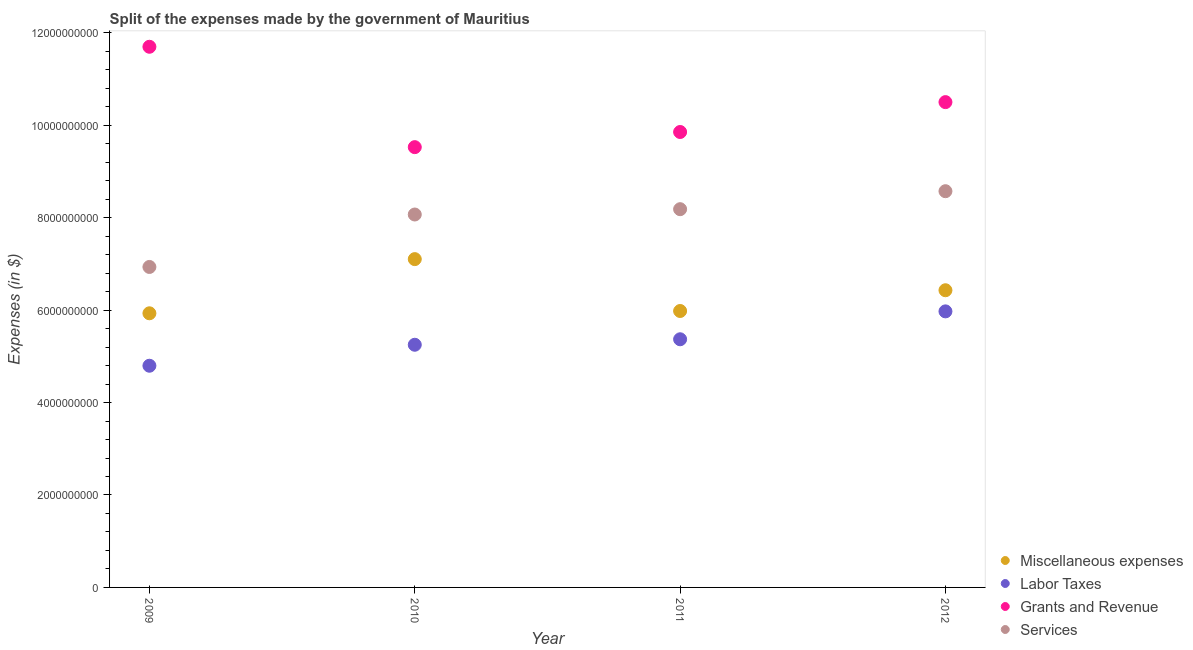Is the number of dotlines equal to the number of legend labels?
Ensure brevity in your answer.  Yes. What is the amount spent on miscellaneous expenses in 2011?
Provide a succinct answer. 5.98e+09. Across all years, what is the maximum amount spent on miscellaneous expenses?
Provide a succinct answer. 7.10e+09. Across all years, what is the minimum amount spent on labor taxes?
Your answer should be compact. 4.80e+09. In which year was the amount spent on grants and revenue maximum?
Your response must be concise. 2009. In which year was the amount spent on miscellaneous expenses minimum?
Ensure brevity in your answer.  2009. What is the total amount spent on services in the graph?
Provide a succinct answer. 3.18e+1. What is the difference between the amount spent on services in 2010 and that in 2012?
Your response must be concise. -5.04e+08. What is the difference between the amount spent on grants and revenue in 2011 and the amount spent on services in 2010?
Your answer should be compact. 1.79e+09. What is the average amount spent on grants and revenue per year?
Your answer should be compact. 1.04e+1. In the year 2010, what is the difference between the amount spent on services and amount spent on grants and revenue?
Give a very brief answer. -1.46e+09. What is the ratio of the amount spent on labor taxes in 2009 to that in 2012?
Your answer should be very brief. 0.8. Is the difference between the amount spent on labor taxes in 2010 and 2012 greater than the difference between the amount spent on grants and revenue in 2010 and 2012?
Provide a succinct answer. Yes. What is the difference between the highest and the second highest amount spent on services?
Provide a short and direct response. 3.89e+08. What is the difference between the highest and the lowest amount spent on services?
Provide a succinct answer. 1.64e+09. Is it the case that in every year, the sum of the amount spent on services and amount spent on miscellaneous expenses is greater than the sum of amount spent on labor taxes and amount spent on grants and revenue?
Provide a short and direct response. No. Does the amount spent on grants and revenue monotonically increase over the years?
Keep it short and to the point. No. Is the amount spent on labor taxes strictly greater than the amount spent on miscellaneous expenses over the years?
Your response must be concise. No. What is the difference between two consecutive major ticks on the Y-axis?
Keep it short and to the point. 2.00e+09. Where does the legend appear in the graph?
Your answer should be very brief. Bottom right. What is the title of the graph?
Offer a terse response. Split of the expenses made by the government of Mauritius. What is the label or title of the X-axis?
Provide a succinct answer. Year. What is the label or title of the Y-axis?
Keep it short and to the point. Expenses (in $). What is the Expenses (in $) in Miscellaneous expenses in 2009?
Make the answer very short. 5.93e+09. What is the Expenses (in $) in Labor Taxes in 2009?
Provide a succinct answer. 4.80e+09. What is the Expenses (in $) in Grants and Revenue in 2009?
Your response must be concise. 1.17e+1. What is the Expenses (in $) in Services in 2009?
Your answer should be very brief. 6.93e+09. What is the Expenses (in $) in Miscellaneous expenses in 2010?
Offer a very short reply. 7.10e+09. What is the Expenses (in $) of Labor Taxes in 2010?
Offer a very short reply. 5.25e+09. What is the Expenses (in $) of Grants and Revenue in 2010?
Offer a terse response. 9.53e+09. What is the Expenses (in $) in Services in 2010?
Provide a short and direct response. 8.07e+09. What is the Expenses (in $) in Miscellaneous expenses in 2011?
Offer a terse response. 5.98e+09. What is the Expenses (in $) of Labor Taxes in 2011?
Your response must be concise. 5.37e+09. What is the Expenses (in $) of Grants and Revenue in 2011?
Give a very brief answer. 9.85e+09. What is the Expenses (in $) of Services in 2011?
Make the answer very short. 8.18e+09. What is the Expenses (in $) in Miscellaneous expenses in 2012?
Your answer should be very brief. 6.43e+09. What is the Expenses (in $) in Labor Taxes in 2012?
Offer a very short reply. 5.97e+09. What is the Expenses (in $) in Grants and Revenue in 2012?
Ensure brevity in your answer.  1.05e+1. What is the Expenses (in $) in Services in 2012?
Make the answer very short. 8.57e+09. Across all years, what is the maximum Expenses (in $) of Miscellaneous expenses?
Ensure brevity in your answer.  7.10e+09. Across all years, what is the maximum Expenses (in $) of Labor Taxes?
Keep it short and to the point. 5.97e+09. Across all years, what is the maximum Expenses (in $) of Grants and Revenue?
Offer a terse response. 1.17e+1. Across all years, what is the maximum Expenses (in $) of Services?
Your answer should be compact. 8.57e+09. Across all years, what is the minimum Expenses (in $) of Miscellaneous expenses?
Provide a short and direct response. 5.93e+09. Across all years, what is the minimum Expenses (in $) in Labor Taxes?
Provide a succinct answer. 4.80e+09. Across all years, what is the minimum Expenses (in $) of Grants and Revenue?
Your response must be concise. 9.53e+09. Across all years, what is the minimum Expenses (in $) in Services?
Provide a succinct answer. 6.93e+09. What is the total Expenses (in $) in Miscellaneous expenses in the graph?
Your response must be concise. 2.54e+1. What is the total Expenses (in $) in Labor Taxes in the graph?
Give a very brief answer. 2.14e+1. What is the total Expenses (in $) of Grants and Revenue in the graph?
Your answer should be very brief. 4.16e+1. What is the total Expenses (in $) in Services in the graph?
Make the answer very short. 3.18e+1. What is the difference between the Expenses (in $) of Miscellaneous expenses in 2009 and that in 2010?
Offer a terse response. -1.17e+09. What is the difference between the Expenses (in $) of Labor Taxes in 2009 and that in 2010?
Provide a succinct answer. -4.54e+08. What is the difference between the Expenses (in $) of Grants and Revenue in 2009 and that in 2010?
Give a very brief answer. 2.17e+09. What is the difference between the Expenses (in $) of Services in 2009 and that in 2010?
Provide a succinct answer. -1.13e+09. What is the difference between the Expenses (in $) of Miscellaneous expenses in 2009 and that in 2011?
Provide a succinct answer. -4.98e+07. What is the difference between the Expenses (in $) in Labor Taxes in 2009 and that in 2011?
Provide a short and direct response. -5.73e+08. What is the difference between the Expenses (in $) in Grants and Revenue in 2009 and that in 2011?
Ensure brevity in your answer.  1.84e+09. What is the difference between the Expenses (in $) of Services in 2009 and that in 2011?
Offer a very short reply. -1.25e+09. What is the difference between the Expenses (in $) in Miscellaneous expenses in 2009 and that in 2012?
Provide a short and direct response. -4.99e+08. What is the difference between the Expenses (in $) in Labor Taxes in 2009 and that in 2012?
Give a very brief answer. -1.18e+09. What is the difference between the Expenses (in $) in Grants and Revenue in 2009 and that in 2012?
Offer a terse response. 1.20e+09. What is the difference between the Expenses (in $) of Services in 2009 and that in 2012?
Make the answer very short. -1.64e+09. What is the difference between the Expenses (in $) in Miscellaneous expenses in 2010 and that in 2011?
Provide a short and direct response. 1.12e+09. What is the difference between the Expenses (in $) in Labor Taxes in 2010 and that in 2011?
Offer a terse response. -1.19e+08. What is the difference between the Expenses (in $) in Grants and Revenue in 2010 and that in 2011?
Your answer should be compact. -3.28e+08. What is the difference between the Expenses (in $) in Services in 2010 and that in 2011?
Give a very brief answer. -1.15e+08. What is the difference between the Expenses (in $) in Miscellaneous expenses in 2010 and that in 2012?
Give a very brief answer. 6.73e+08. What is the difference between the Expenses (in $) in Labor Taxes in 2010 and that in 2012?
Your answer should be compact. -7.22e+08. What is the difference between the Expenses (in $) of Grants and Revenue in 2010 and that in 2012?
Provide a succinct answer. -9.74e+08. What is the difference between the Expenses (in $) of Services in 2010 and that in 2012?
Provide a short and direct response. -5.04e+08. What is the difference between the Expenses (in $) of Miscellaneous expenses in 2011 and that in 2012?
Your response must be concise. -4.49e+08. What is the difference between the Expenses (in $) of Labor Taxes in 2011 and that in 2012?
Ensure brevity in your answer.  -6.04e+08. What is the difference between the Expenses (in $) of Grants and Revenue in 2011 and that in 2012?
Ensure brevity in your answer.  -6.46e+08. What is the difference between the Expenses (in $) of Services in 2011 and that in 2012?
Provide a succinct answer. -3.89e+08. What is the difference between the Expenses (in $) of Miscellaneous expenses in 2009 and the Expenses (in $) of Labor Taxes in 2010?
Your response must be concise. 6.81e+08. What is the difference between the Expenses (in $) in Miscellaneous expenses in 2009 and the Expenses (in $) in Grants and Revenue in 2010?
Keep it short and to the point. -3.59e+09. What is the difference between the Expenses (in $) in Miscellaneous expenses in 2009 and the Expenses (in $) in Services in 2010?
Ensure brevity in your answer.  -2.14e+09. What is the difference between the Expenses (in $) of Labor Taxes in 2009 and the Expenses (in $) of Grants and Revenue in 2010?
Your answer should be compact. -4.73e+09. What is the difference between the Expenses (in $) in Labor Taxes in 2009 and the Expenses (in $) in Services in 2010?
Provide a short and direct response. -3.27e+09. What is the difference between the Expenses (in $) of Grants and Revenue in 2009 and the Expenses (in $) of Services in 2010?
Your answer should be very brief. 3.63e+09. What is the difference between the Expenses (in $) in Miscellaneous expenses in 2009 and the Expenses (in $) in Labor Taxes in 2011?
Offer a terse response. 5.62e+08. What is the difference between the Expenses (in $) of Miscellaneous expenses in 2009 and the Expenses (in $) of Grants and Revenue in 2011?
Offer a very short reply. -3.92e+09. What is the difference between the Expenses (in $) in Miscellaneous expenses in 2009 and the Expenses (in $) in Services in 2011?
Give a very brief answer. -2.25e+09. What is the difference between the Expenses (in $) of Labor Taxes in 2009 and the Expenses (in $) of Grants and Revenue in 2011?
Offer a very short reply. -5.06e+09. What is the difference between the Expenses (in $) in Labor Taxes in 2009 and the Expenses (in $) in Services in 2011?
Your answer should be very brief. -3.39e+09. What is the difference between the Expenses (in $) of Grants and Revenue in 2009 and the Expenses (in $) of Services in 2011?
Your answer should be very brief. 3.51e+09. What is the difference between the Expenses (in $) in Miscellaneous expenses in 2009 and the Expenses (in $) in Labor Taxes in 2012?
Keep it short and to the point. -4.15e+07. What is the difference between the Expenses (in $) of Miscellaneous expenses in 2009 and the Expenses (in $) of Grants and Revenue in 2012?
Give a very brief answer. -4.57e+09. What is the difference between the Expenses (in $) of Miscellaneous expenses in 2009 and the Expenses (in $) of Services in 2012?
Your answer should be very brief. -2.64e+09. What is the difference between the Expenses (in $) of Labor Taxes in 2009 and the Expenses (in $) of Grants and Revenue in 2012?
Your answer should be compact. -5.70e+09. What is the difference between the Expenses (in $) in Labor Taxes in 2009 and the Expenses (in $) in Services in 2012?
Ensure brevity in your answer.  -3.78e+09. What is the difference between the Expenses (in $) of Grants and Revenue in 2009 and the Expenses (in $) of Services in 2012?
Ensure brevity in your answer.  3.12e+09. What is the difference between the Expenses (in $) of Miscellaneous expenses in 2010 and the Expenses (in $) of Labor Taxes in 2011?
Offer a very short reply. 1.73e+09. What is the difference between the Expenses (in $) of Miscellaneous expenses in 2010 and the Expenses (in $) of Grants and Revenue in 2011?
Make the answer very short. -2.75e+09. What is the difference between the Expenses (in $) of Miscellaneous expenses in 2010 and the Expenses (in $) of Services in 2011?
Provide a short and direct response. -1.08e+09. What is the difference between the Expenses (in $) in Labor Taxes in 2010 and the Expenses (in $) in Grants and Revenue in 2011?
Offer a terse response. -4.60e+09. What is the difference between the Expenses (in $) of Labor Taxes in 2010 and the Expenses (in $) of Services in 2011?
Keep it short and to the point. -2.93e+09. What is the difference between the Expenses (in $) of Grants and Revenue in 2010 and the Expenses (in $) of Services in 2011?
Offer a very short reply. 1.34e+09. What is the difference between the Expenses (in $) in Miscellaneous expenses in 2010 and the Expenses (in $) in Labor Taxes in 2012?
Ensure brevity in your answer.  1.13e+09. What is the difference between the Expenses (in $) of Miscellaneous expenses in 2010 and the Expenses (in $) of Grants and Revenue in 2012?
Keep it short and to the point. -3.40e+09. What is the difference between the Expenses (in $) in Miscellaneous expenses in 2010 and the Expenses (in $) in Services in 2012?
Make the answer very short. -1.47e+09. What is the difference between the Expenses (in $) in Labor Taxes in 2010 and the Expenses (in $) in Grants and Revenue in 2012?
Provide a short and direct response. -5.25e+09. What is the difference between the Expenses (in $) of Labor Taxes in 2010 and the Expenses (in $) of Services in 2012?
Give a very brief answer. -3.32e+09. What is the difference between the Expenses (in $) of Grants and Revenue in 2010 and the Expenses (in $) of Services in 2012?
Make the answer very short. 9.53e+08. What is the difference between the Expenses (in $) in Miscellaneous expenses in 2011 and the Expenses (in $) in Labor Taxes in 2012?
Offer a terse response. 8.30e+06. What is the difference between the Expenses (in $) in Miscellaneous expenses in 2011 and the Expenses (in $) in Grants and Revenue in 2012?
Give a very brief answer. -4.52e+09. What is the difference between the Expenses (in $) in Miscellaneous expenses in 2011 and the Expenses (in $) in Services in 2012?
Offer a terse response. -2.59e+09. What is the difference between the Expenses (in $) of Labor Taxes in 2011 and the Expenses (in $) of Grants and Revenue in 2012?
Give a very brief answer. -5.13e+09. What is the difference between the Expenses (in $) of Labor Taxes in 2011 and the Expenses (in $) of Services in 2012?
Offer a very short reply. -3.20e+09. What is the difference between the Expenses (in $) in Grants and Revenue in 2011 and the Expenses (in $) in Services in 2012?
Your answer should be very brief. 1.28e+09. What is the average Expenses (in $) of Miscellaneous expenses per year?
Provide a succinct answer. 6.36e+09. What is the average Expenses (in $) of Labor Taxes per year?
Offer a terse response. 5.35e+09. What is the average Expenses (in $) of Grants and Revenue per year?
Offer a very short reply. 1.04e+1. What is the average Expenses (in $) of Services per year?
Give a very brief answer. 7.94e+09. In the year 2009, what is the difference between the Expenses (in $) in Miscellaneous expenses and Expenses (in $) in Labor Taxes?
Your answer should be very brief. 1.13e+09. In the year 2009, what is the difference between the Expenses (in $) of Miscellaneous expenses and Expenses (in $) of Grants and Revenue?
Your answer should be compact. -5.77e+09. In the year 2009, what is the difference between the Expenses (in $) in Miscellaneous expenses and Expenses (in $) in Services?
Provide a succinct answer. -1.00e+09. In the year 2009, what is the difference between the Expenses (in $) of Labor Taxes and Expenses (in $) of Grants and Revenue?
Provide a succinct answer. -6.90e+09. In the year 2009, what is the difference between the Expenses (in $) of Labor Taxes and Expenses (in $) of Services?
Ensure brevity in your answer.  -2.14e+09. In the year 2009, what is the difference between the Expenses (in $) in Grants and Revenue and Expenses (in $) in Services?
Provide a short and direct response. 4.76e+09. In the year 2010, what is the difference between the Expenses (in $) in Miscellaneous expenses and Expenses (in $) in Labor Taxes?
Your answer should be compact. 1.85e+09. In the year 2010, what is the difference between the Expenses (in $) in Miscellaneous expenses and Expenses (in $) in Grants and Revenue?
Your answer should be compact. -2.42e+09. In the year 2010, what is the difference between the Expenses (in $) in Miscellaneous expenses and Expenses (in $) in Services?
Make the answer very short. -9.65e+08. In the year 2010, what is the difference between the Expenses (in $) of Labor Taxes and Expenses (in $) of Grants and Revenue?
Your response must be concise. -4.28e+09. In the year 2010, what is the difference between the Expenses (in $) of Labor Taxes and Expenses (in $) of Services?
Offer a terse response. -2.82e+09. In the year 2010, what is the difference between the Expenses (in $) in Grants and Revenue and Expenses (in $) in Services?
Offer a very short reply. 1.46e+09. In the year 2011, what is the difference between the Expenses (in $) of Miscellaneous expenses and Expenses (in $) of Labor Taxes?
Your answer should be compact. 6.12e+08. In the year 2011, what is the difference between the Expenses (in $) of Miscellaneous expenses and Expenses (in $) of Grants and Revenue?
Your answer should be compact. -3.87e+09. In the year 2011, what is the difference between the Expenses (in $) of Miscellaneous expenses and Expenses (in $) of Services?
Keep it short and to the point. -2.20e+09. In the year 2011, what is the difference between the Expenses (in $) of Labor Taxes and Expenses (in $) of Grants and Revenue?
Make the answer very short. -4.48e+09. In the year 2011, what is the difference between the Expenses (in $) of Labor Taxes and Expenses (in $) of Services?
Ensure brevity in your answer.  -2.81e+09. In the year 2011, what is the difference between the Expenses (in $) in Grants and Revenue and Expenses (in $) in Services?
Your answer should be compact. 1.67e+09. In the year 2012, what is the difference between the Expenses (in $) in Miscellaneous expenses and Expenses (in $) in Labor Taxes?
Give a very brief answer. 4.57e+08. In the year 2012, what is the difference between the Expenses (in $) in Miscellaneous expenses and Expenses (in $) in Grants and Revenue?
Provide a succinct answer. -4.07e+09. In the year 2012, what is the difference between the Expenses (in $) in Miscellaneous expenses and Expenses (in $) in Services?
Provide a succinct answer. -2.14e+09. In the year 2012, what is the difference between the Expenses (in $) in Labor Taxes and Expenses (in $) in Grants and Revenue?
Provide a short and direct response. -4.53e+09. In the year 2012, what is the difference between the Expenses (in $) of Labor Taxes and Expenses (in $) of Services?
Offer a terse response. -2.60e+09. In the year 2012, what is the difference between the Expenses (in $) of Grants and Revenue and Expenses (in $) of Services?
Your answer should be very brief. 1.93e+09. What is the ratio of the Expenses (in $) in Miscellaneous expenses in 2009 to that in 2010?
Your answer should be very brief. 0.83. What is the ratio of the Expenses (in $) in Labor Taxes in 2009 to that in 2010?
Your answer should be very brief. 0.91. What is the ratio of the Expenses (in $) in Grants and Revenue in 2009 to that in 2010?
Your answer should be very brief. 1.23. What is the ratio of the Expenses (in $) in Services in 2009 to that in 2010?
Your answer should be compact. 0.86. What is the ratio of the Expenses (in $) in Miscellaneous expenses in 2009 to that in 2011?
Your answer should be compact. 0.99. What is the ratio of the Expenses (in $) in Labor Taxes in 2009 to that in 2011?
Provide a succinct answer. 0.89. What is the ratio of the Expenses (in $) of Grants and Revenue in 2009 to that in 2011?
Ensure brevity in your answer.  1.19. What is the ratio of the Expenses (in $) in Services in 2009 to that in 2011?
Provide a short and direct response. 0.85. What is the ratio of the Expenses (in $) in Miscellaneous expenses in 2009 to that in 2012?
Make the answer very short. 0.92. What is the ratio of the Expenses (in $) of Labor Taxes in 2009 to that in 2012?
Offer a very short reply. 0.8. What is the ratio of the Expenses (in $) in Grants and Revenue in 2009 to that in 2012?
Offer a terse response. 1.11. What is the ratio of the Expenses (in $) of Services in 2009 to that in 2012?
Provide a short and direct response. 0.81. What is the ratio of the Expenses (in $) of Miscellaneous expenses in 2010 to that in 2011?
Offer a terse response. 1.19. What is the ratio of the Expenses (in $) of Labor Taxes in 2010 to that in 2011?
Your response must be concise. 0.98. What is the ratio of the Expenses (in $) in Grants and Revenue in 2010 to that in 2011?
Make the answer very short. 0.97. What is the ratio of the Expenses (in $) in Services in 2010 to that in 2011?
Your answer should be very brief. 0.99. What is the ratio of the Expenses (in $) in Miscellaneous expenses in 2010 to that in 2012?
Offer a very short reply. 1.1. What is the ratio of the Expenses (in $) of Labor Taxes in 2010 to that in 2012?
Your response must be concise. 0.88. What is the ratio of the Expenses (in $) of Grants and Revenue in 2010 to that in 2012?
Make the answer very short. 0.91. What is the ratio of the Expenses (in $) of Miscellaneous expenses in 2011 to that in 2012?
Ensure brevity in your answer.  0.93. What is the ratio of the Expenses (in $) in Labor Taxes in 2011 to that in 2012?
Ensure brevity in your answer.  0.9. What is the ratio of the Expenses (in $) in Grants and Revenue in 2011 to that in 2012?
Your answer should be very brief. 0.94. What is the ratio of the Expenses (in $) in Services in 2011 to that in 2012?
Offer a very short reply. 0.95. What is the difference between the highest and the second highest Expenses (in $) of Miscellaneous expenses?
Give a very brief answer. 6.73e+08. What is the difference between the highest and the second highest Expenses (in $) in Labor Taxes?
Ensure brevity in your answer.  6.04e+08. What is the difference between the highest and the second highest Expenses (in $) of Grants and Revenue?
Keep it short and to the point. 1.20e+09. What is the difference between the highest and the second highest Expenses (in $) in Services?
Your answer should be compact. 3.89e+08. What is the difference between the highest and the lowest Expenses (in $) of Miscellaneous expenses?
Provide a short and direct response. 1.17e+09. What is the difference between the highest and the lowest Expenses (in $) of Labor Taxes?
Your answer should be compact. 1.18e+09. What is the difference between the highest and the lowest Expenses (in $) in Grants and Revenue?
Make the answer very short. 2.17e+09. What is the difference between the highest and the lowest Expenses (in $) of Services?
Your answer should be compact. 1.64e+09. 